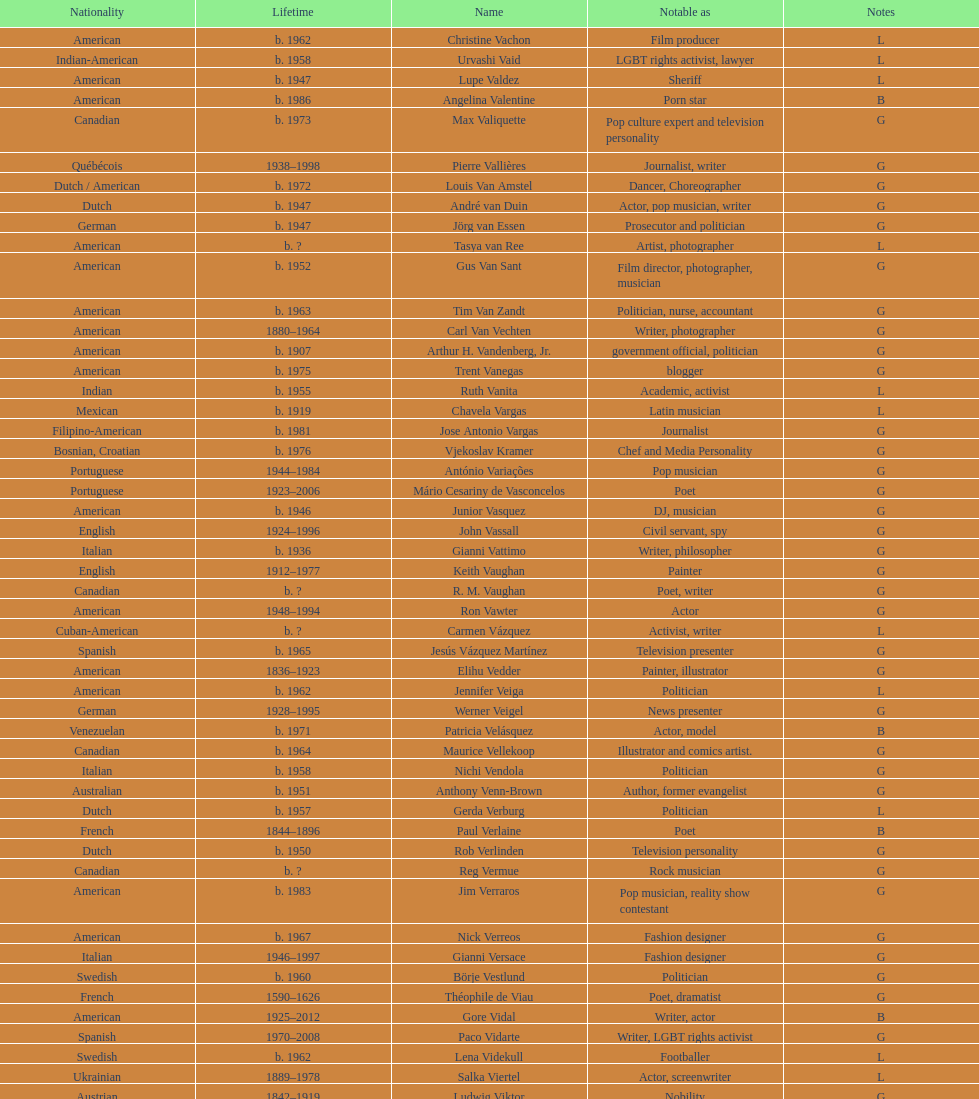Who lived longer, van vechten or variacoes? Van Vechten. 